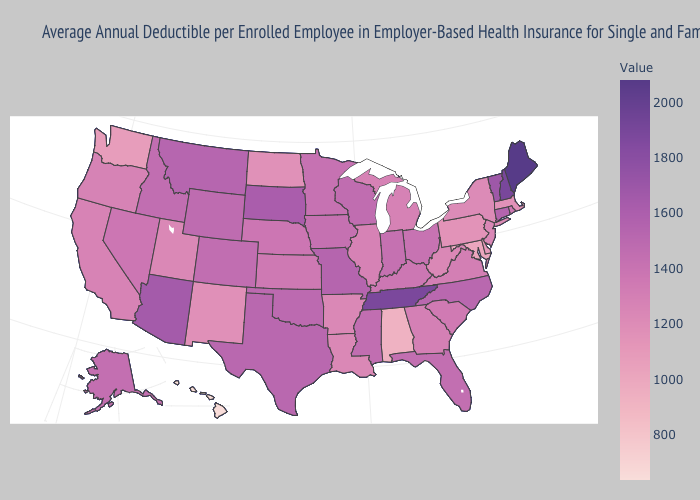Which states have the lowest value in the USA?
Concise answer only. Hawaii. Is the legend a continuous bar?
Be succinct. Yes. Among the states that border Michigan , does Ohio have the highest value?
Concise answer only. No. Which states have the lowest value in the MidWest?
Write a very short answer. North Dakota. Does Maine have a lower value than Oklahoma?
Keep it brief. No. Among the states that border Wyoming , does South Dakota have the highest value?
Concise answer only. Yes. Which states have the lowest value in the Northeast?
Write a very short answer. Pennsylvania. Which states hav the highest value in the West?
Keep it brief. Arizona. 